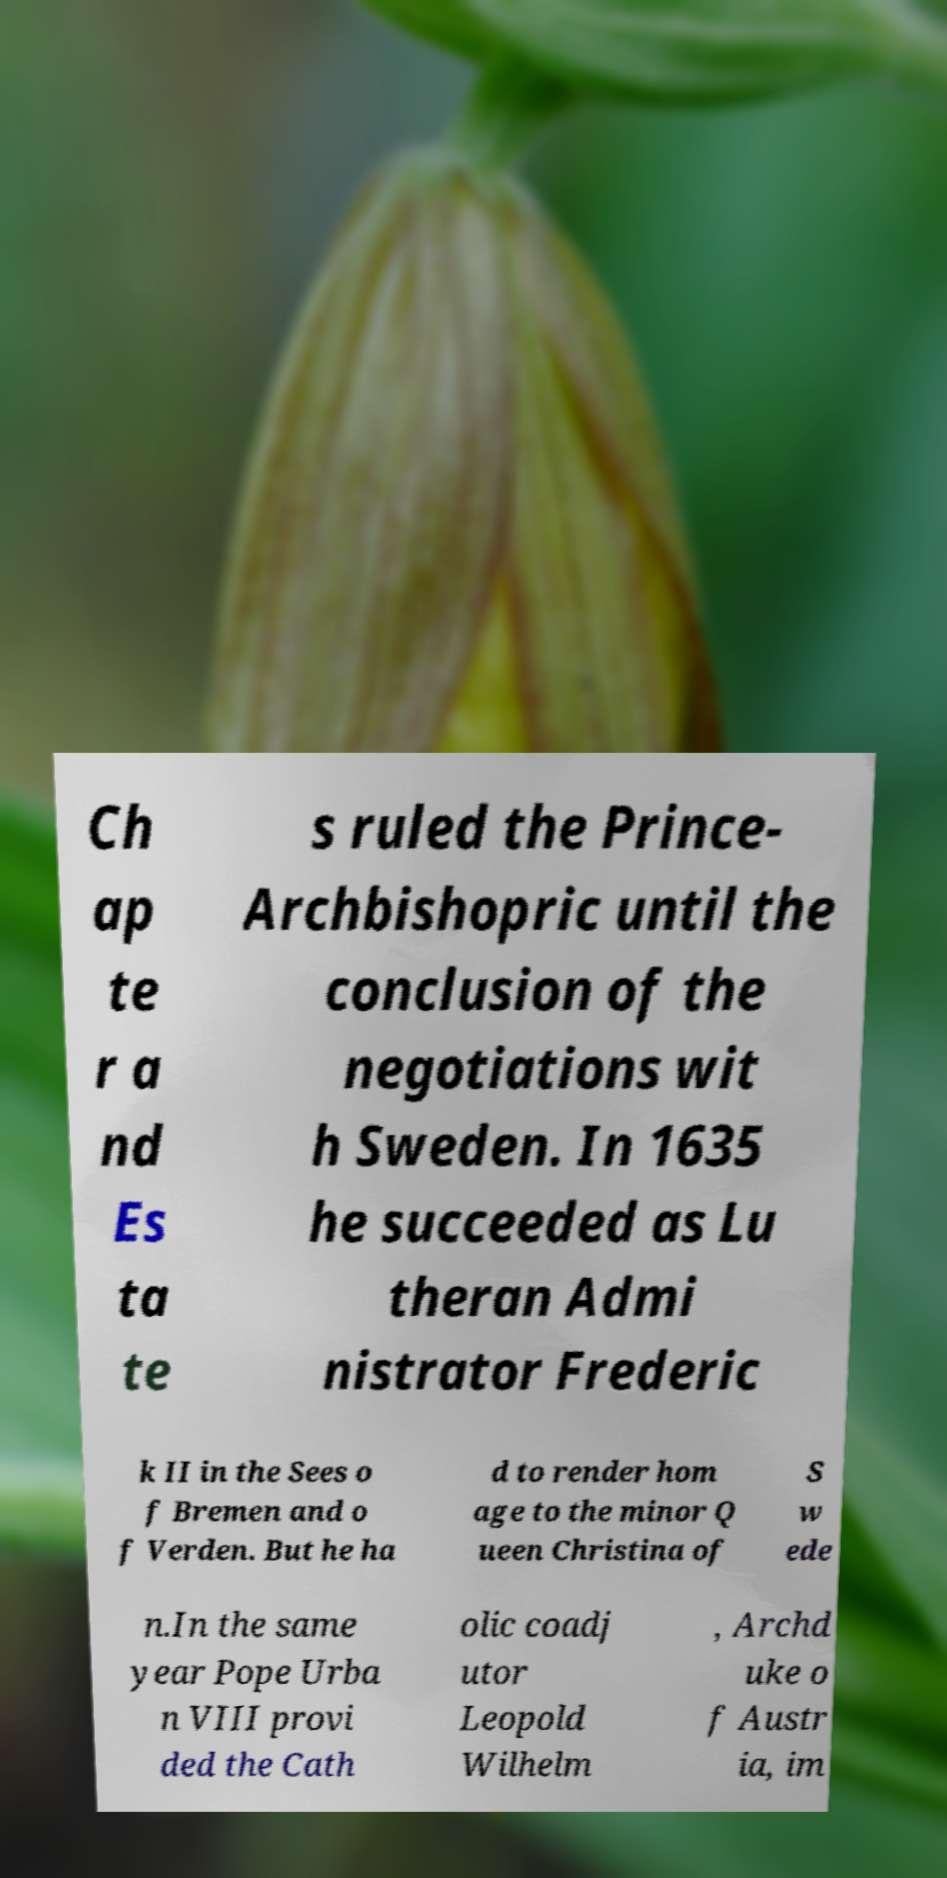There's text embedded in this image that I need extracted. Can you transcribe it verbatim? Ch ap te r a nd Es ta te s ruled the Prince- Archbishopric until the conclusion of the negotiations wit h Sweden. In 1635 he succeeded as Lu theran Admi nistrator Frederic k II in the Sees o f Bremen and o f Verden. But he ha d to render hom age to the minor Q ueen Christina of S w ede n.In the same year Pope Urba n VIII provi ded the Cath olic coadj utor Leopold Wilhelm , Archd uke o f Austr ia, im 